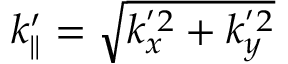<formula> <loc_0><loc_0><loc_500><loc_500>k _ { \| } ^ { \prime } = \sqrt { k _ { x } ^ { ^ { \prime } 2 } + k _ { y } ^ { ^ { \prime } 2 } }</formula> 